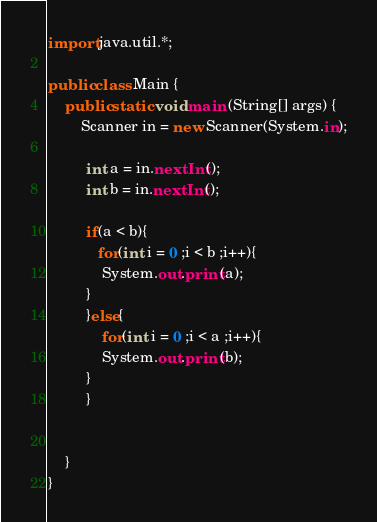Convert code to text. <code><loc_0><loc_0><loc_500><loc_500><_Java_>import java.util.*;
 
public class Main {
	public static void main (String[] args) {
		Scanner in = new Scanner(System.in);
		
		 int a = in.nextInt();
		 int b = in.nextInt();
		 
		 if(a < b){
		    for(int i = 0 ;i < b ;i++){
		     System.out.print(a);
		 }
		 }else{
		     for(int i = 0 ;i < a ;i++){
		     System.out.print(b);
		 }
		 }

      
	}
}</code> 